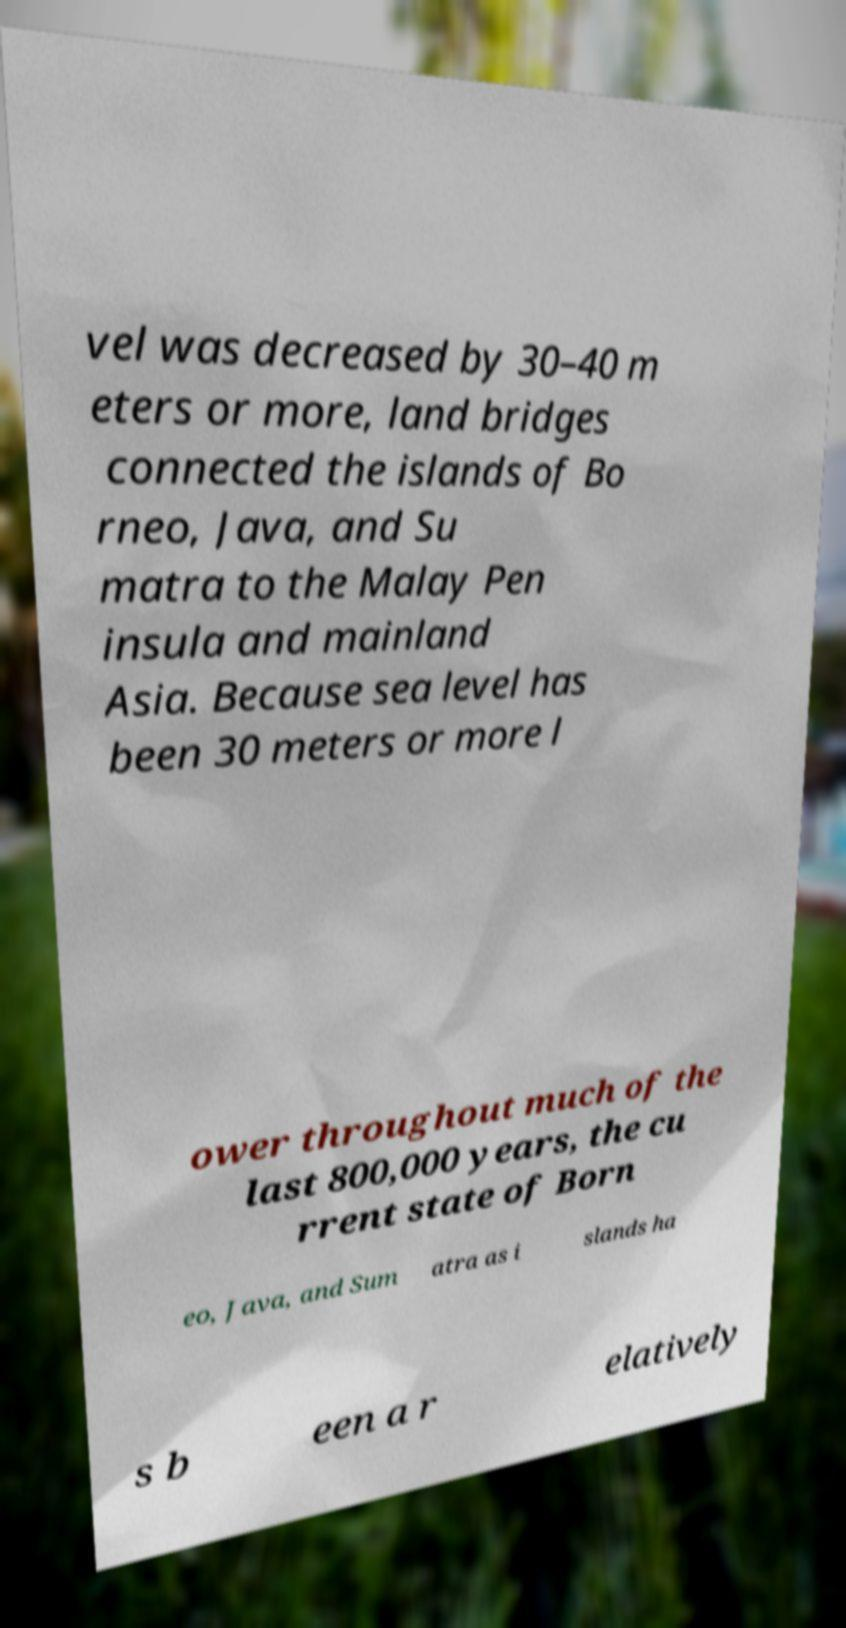For documentation purposes, I need the text within this image transcribed. Could you provide that? vel was decreased by 30–40 m eters or more, land bridges connected the islands of Bo rneo, Java, and Su matra to the Malay Pen insula and mainland Asia. Because sea level has been 30 meters or more l ower throughout much of the last 800,000 years, the cu rrent state of Born eo, Java, and Sum atra as i slands ha s b een a r elatively 